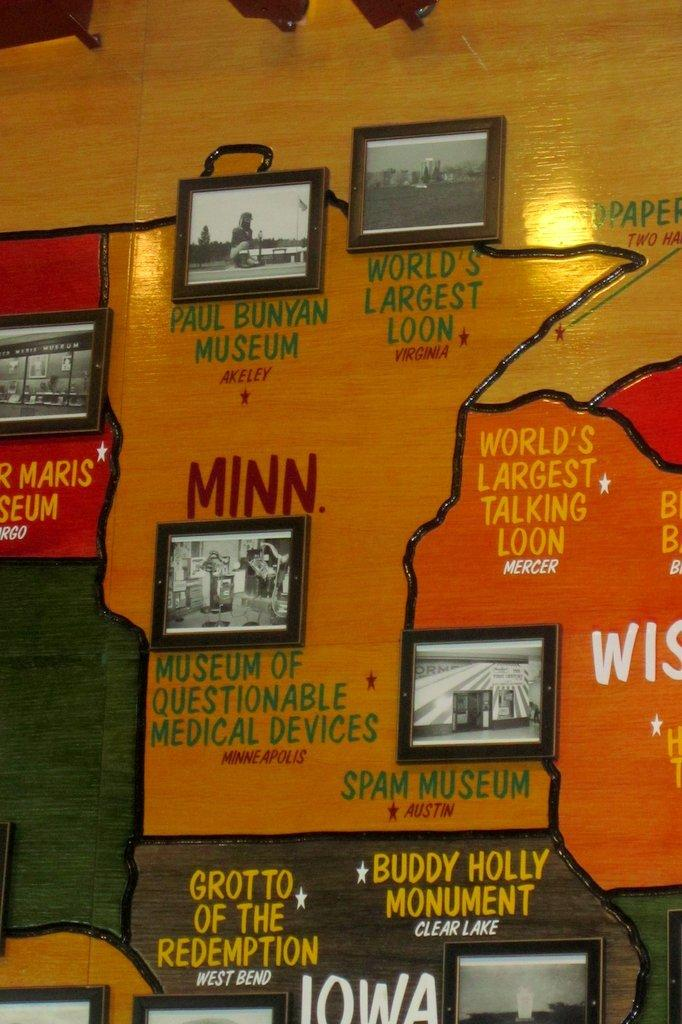Provide a one-sentence caption for the provided image. A list of odd museums including the Museum of Questionable Medical Devices. 